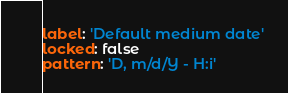Convert code to text. <code><loc_0><loc_0><loc_500><loc_500><_YAML_>label: 'Default medium date'
locked: false
pattern: 'D, m/d/Y - H:i'
</code> 